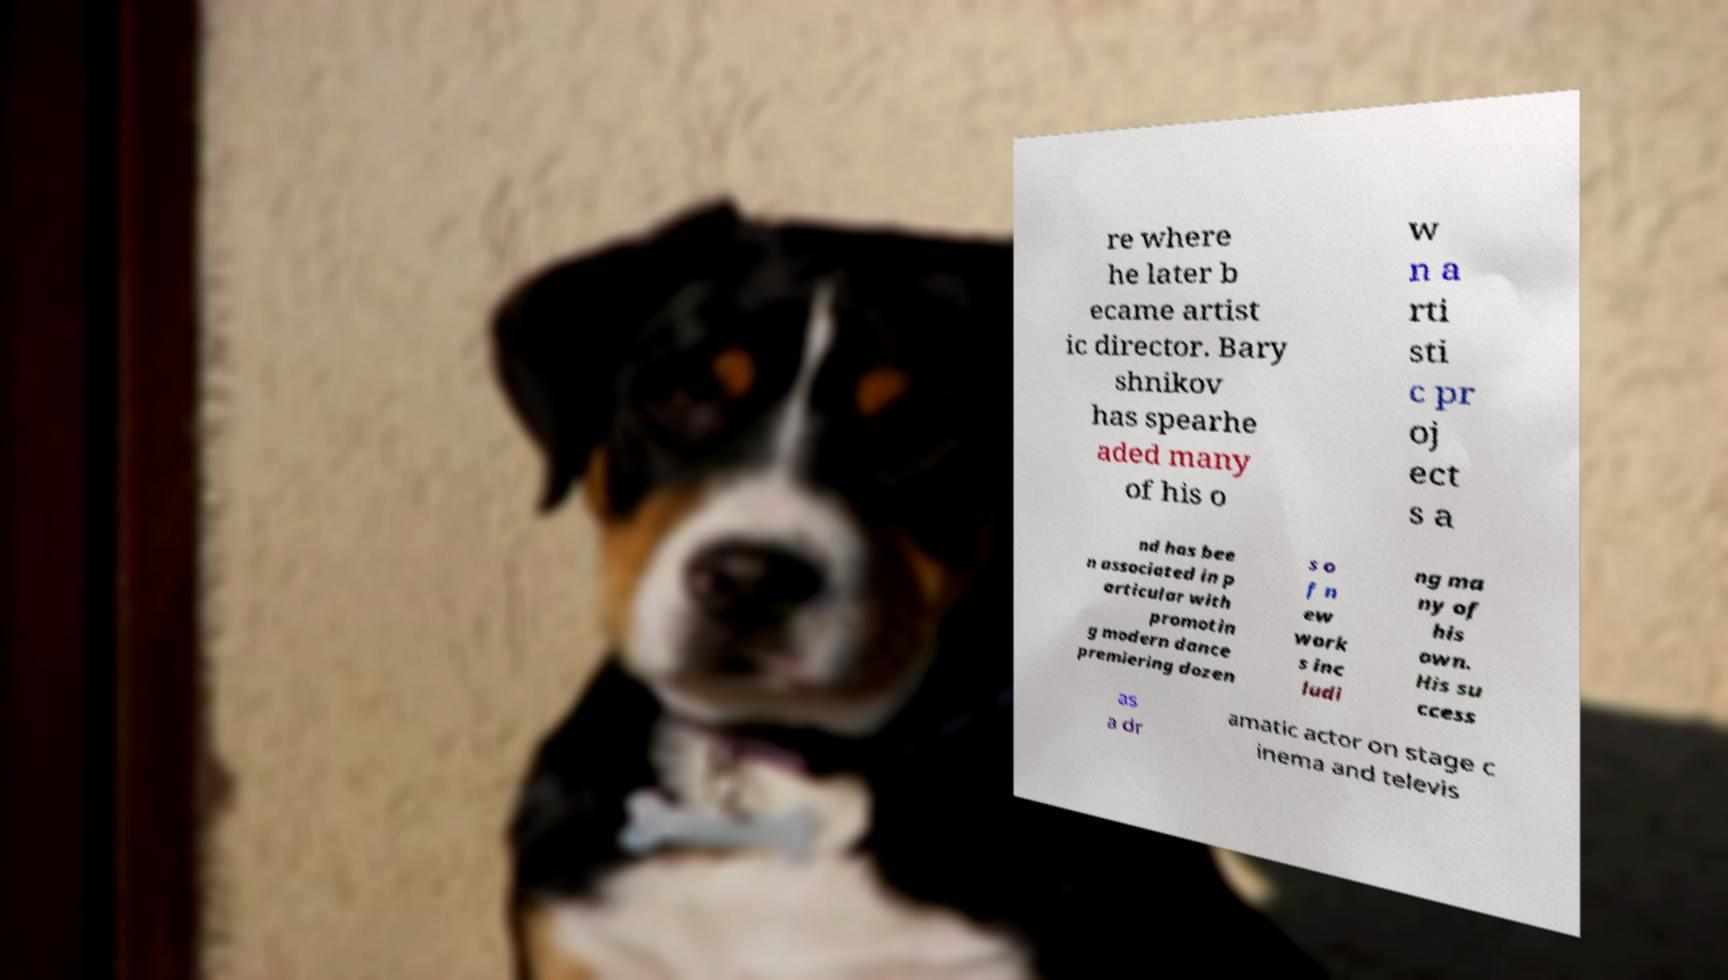Can you read and provide the text displayed in the image?This photo seems to have some interesting text. Can you extract and type it out for me? re where he later b ecame artist ic director. Bary shnikov has spearhe aded many of his o w n a rti sti c pr oj ect s a nd has bee n associated in p articular with promotin g modern dance premiering dozen s o f n ew work s inc ludi ng ma ny of his own. His su ccess as a dr amatic actor on stage c inema and televis 